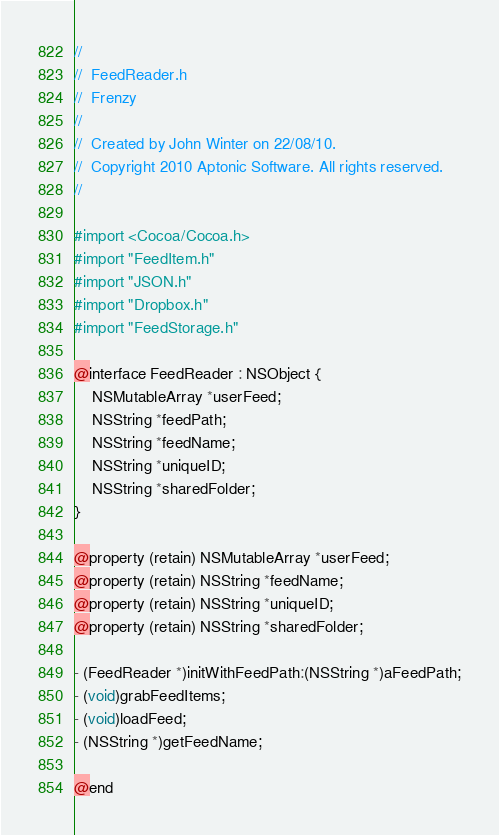<code> <loc_0><loc_0><loc_500><loc_500><_C_>//
//  FeedReader.h
//  Frenzy
//
//  Created by John Winter on 22/08/10.
//  Copyright 2010 Aptonic Software. All rights reserved.
//

#import <Cocoa/Cocoa.h>
#import "FeedItem.h"
#import "JSON.h"
#import "Dropbox.h"
#import "FeedStorage.h"

@interface FeedReader : NSObject {
	NSMutableArray *userFeed;
	NSString *feedPath;
	NSString *feedName;
	NSString *uniqueID;
	NSString *sharedFolder;
}

@property (retain) NSMutableArray *userFeed;
@property (retain) NSString *feedName;
@property (retain) NSString *uniqueID;
@property (retain) NSString *sharedFolder;

- (FeedReader *)initWithFeedPath:(NSString *)aFeedPath;
- (void)grabFeedItems;
- (void)loadFeed;
- (NSString *)getFeedName;

@end
</code> 